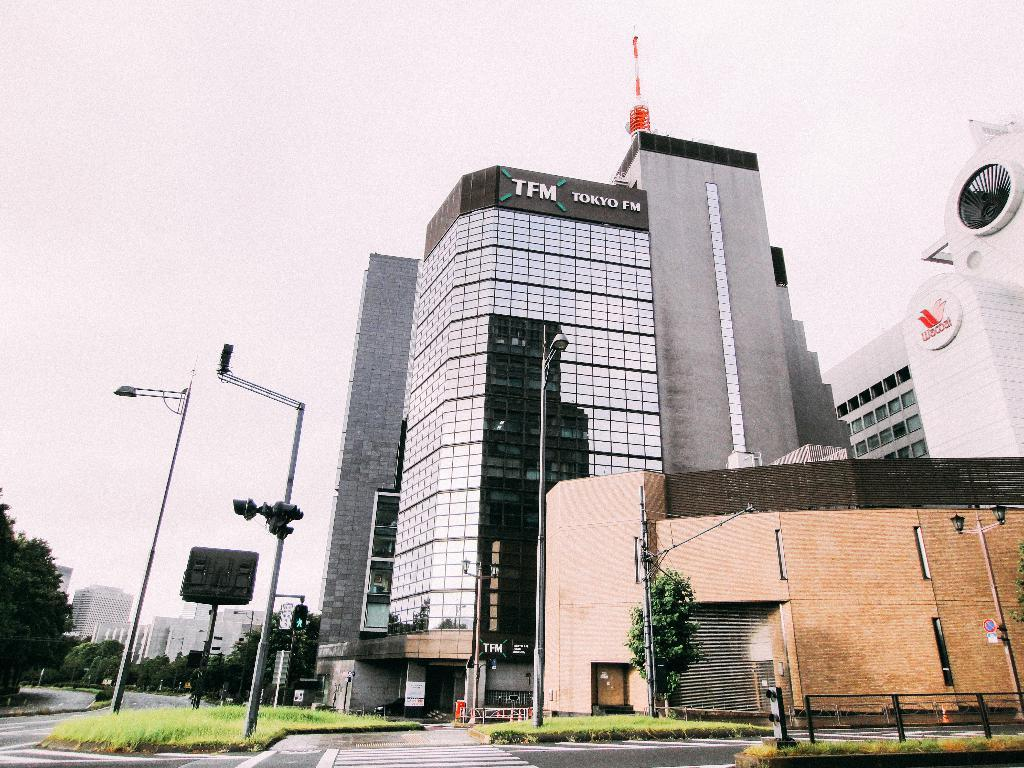What type of buildings can be seen in the image? There are buildings with glass windows in the image. What structures are present to provide illumination at night? There are light poles in the image. What type of vegetation is visible in the image? There are trees in the image. What type of ground cover is present in the image? There is grass in the image. How much money is being exchanged between the cast members in the image? There is no cast present in the image, and therefore no money exchange can be observed. What type of street is visible in the image? There is no street visible in the image; it features buildings, light poles, trees, and grass. 